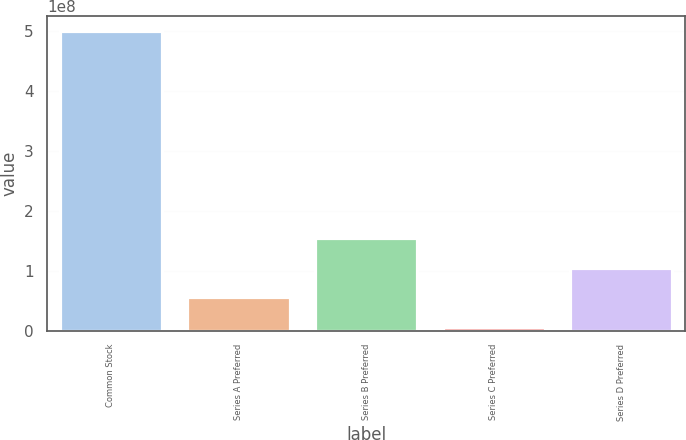Convert chart to OTSL. <chart><loc_0><loc_0><loc_500><loc_500><bar_chart><fcel>Common Stock<fcel>Series A Preferred<fcel>Series B Preferred<fcel>Series C Preferred<fcel>Series D Preferred<nl><fcel>5e+08<fcel>5.54e+07<fcel>1.542e+08<fcel>6e+06<fcel>1.048e+08<nl></chart> 